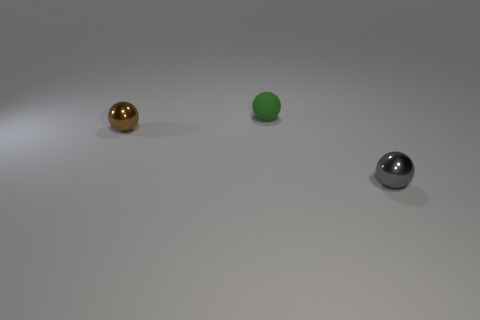Subtract all blue balls. Subtract all green blocks. How many balls are left? 3 Add 3 brown metallic things. How many objects exist? 6 Add 2 gray things. How many gray things exist? 3 Subtract 0 gray cubes. How many objects are left? 3 Subtract all tiny gray metallic spheres. Subtract all brown objects. How many objects are left? 1 Add 2 green matte balls. How many green matte balls are left? 3 